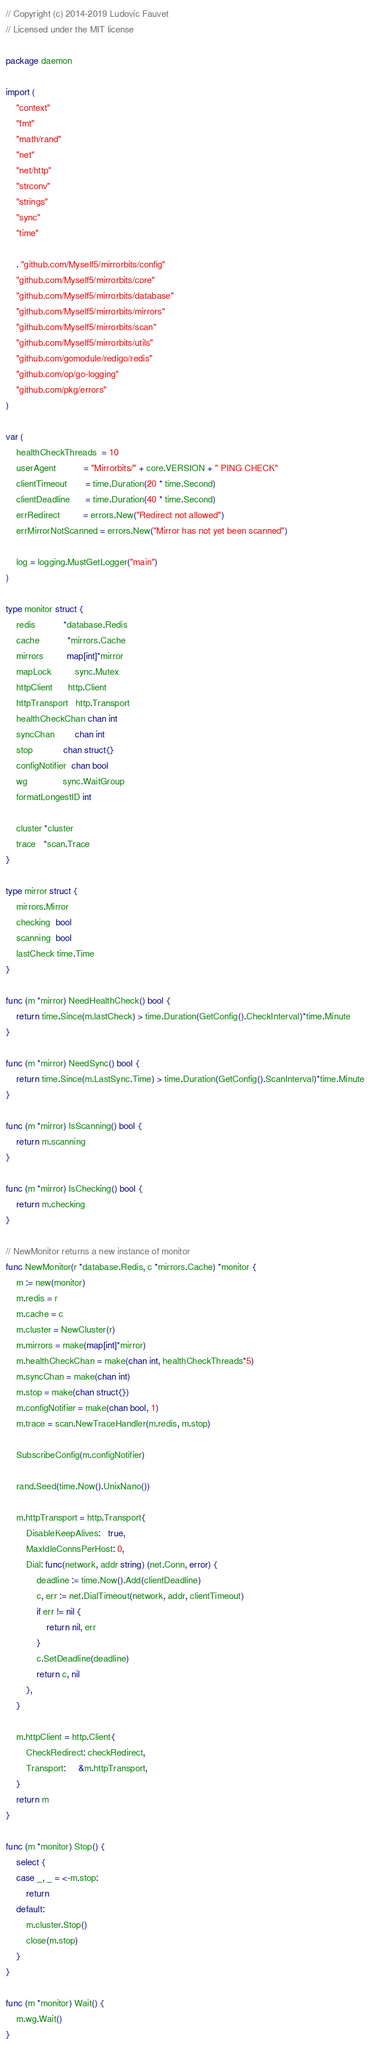<code> <loc_0><loc_0><loc_500><loc_500><_Go_>// Copyright (c) 2014-2019 Ludovic Fauvet
// Licensed under the MIT license

package daemon

import (
	"context"
	"fmt"
	"math/rand"
	"net"
	"net/http"
	"strconv"
	"strings"
	"sync"
	"time"

	. "github.com/Myself5/mirrorbits/config"
	"github.com/Myself5/mirrorbits/core"
	"github.com/Myself5/mirrorbits/database"
	"github.com/Myself5/mirrorbits/mirrors"
	"github.com/Myself5/mirrorbits/scan"
	"github.com/Myself5/mirrorbits/utils"
	"github.com/gomodule/redigo/redis"
	"github.com/op/go-logging"
	"github.com/pkg/errors"
)

var (
	healthCheckThreads  = 10
	userAgent           = "Mirrorbits/" + core.VERSION + " PING CHECK"
	clientTimeout       = time.Duration(20 * time.Second)
	clientDeadline      = time.Duration(40 * time.Second)
	errRedirect         = errors.New("Redirect not allowed")
	errMirrorNotScanned = errors.New("Mirror has not yet been scanned")

	log = logging.MustGetLogger("main")
)

type monitor struct {
	redis           *database.Redis
	cache           *mirrors.Cache
	mirrors         map[int]*mirror
	mapLock         sync.Mutex
	httpClient      http.Client
	httpTransport   http.Transport
	healthCheckChan chan int
	syncChan        chan int
	stop            chan struct{}
	configNotifier  chan bool
	wg              sync.WaitGroup
	formatLongestID int

	cluster *cluster
	trace   *scan.Trace
}

type mirror struct {
	mirrors.Mirror
	checking  bool
	scanning  bool
	lastCheck time.Time
}

func (m *mirror) NeedHealthCheck() bool {
	return time.Since(m.lastCheck) > time.Duration(GetConfig().CheckInterval)*time.Minute
}

func (m *mirror) NeedSync() bool {
	return time.Since(m.LastSync.Time) > time.Duration(GetConfig().ScanInterval)*time.Minute
}

func (m *mirror) IsScanning() bool {
	return m.scanning
}

func (m *mirror) IsChecking() bool {
	return m.checking
}

// NewMonitor returns a new instance of monitor
func NewMonitor(r *database.Redis, c *mirrors.Cache) *monitor {
	m := new(monitor)
	m.redis = r
	m.cache = c
	m.cluster = NewCluster(r)
	m.mirrors = make(map[int]*mirror)
	m.healthCheckChan = make(chan int, healthCheckThreads*5)
	m.syncChan = make(chan int)
	m.stop = make(chan struct{})
	m.configNotifier = make(chan bool, 1)
	m.trace = scan.NewTraceHandler(m.redis, m.stop)

	SubscribeConfig(m.configNotifier)

	rand.Seed(time.Now().UnixNano())

	m.httpTransport = http.Transport{
		DisableKeepAlives:   true,
		MaxIdleConnsPerHost: 0,
		Dial: func(network, addr string) (net.Conn, error) {
			deadline := time.Now().Add(clientDeadline)
			c, err := net.DialTimeout(network, addr, clientTimeout)
			if err != nil {
				return nil, err
			}
			c.SetDeadline(deadline)
			return c, nil
		},
	}

	m.httpClient = http.Client{
		CheckRedirect: checkRedirect,
		Transport:     &m.httpTransport,
	}
	return m
}

func (m *monitor) Stop() {
	select {
	case _, _ = <-m.stop:
		return
	default:
		m.cluster.Stop()
		close(m.stop)
	}
}

func (m *monitor) Wait() {
	m.wg.Wait()
}
</code> 